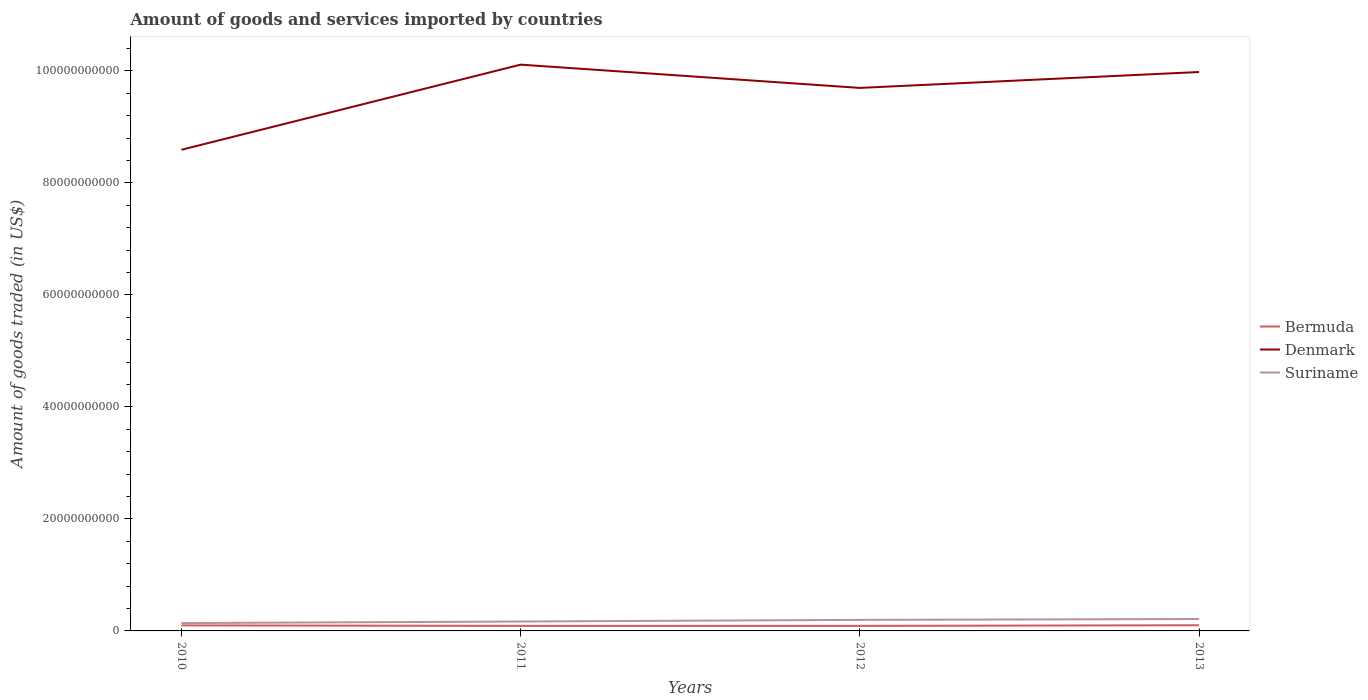How many different coloured lines are there?
Ensure brevity in your answer.  3. Across all years, what is the maximum total amount of goods and services imported in Denmark?
Offer a very short reply. 8.59e+1. What is the total total amount of goods and services imported in Suriname in the graph?
Give a very brief answer. -2.81e+08. What is the difference between the highest and the second highest total amount of goods and services imported in Denmark?
Your answer should be compact. 1.52e+1. What is the difference between the highest and the lowest total amount of goods and services imported in Bermuda?
Provide a short and direct response. 2. Is the total amount of goods and services imported in Denmark strictly greater than the total amount of goods and services imported in Suriname over the years?
Keep it short and to the point. No. What is the difference between two consecutive major ticks on the Y-axis?
Your response must be concise. 2.00e+1. Are the values on the major ticks of Y-axis written in scientific E-notation?
Your answer should be very brief. No. Does the graph contain any zero values?
Your answer should be compact. No. Does the graph contain grids?
Give a very brief answer. No. Where does the legend appear in the graph?
Provide a short and direct response. Center right. How many legend labels are there?
Your answer should be very brief. 3. How are the legend labels stacked?
Your answer should be very brief. Vertical. What is the title of the graph?
Offer a terse response. Amount of goods and services imported by countries. Does "Gambia, The" appear as one of the legend labels in the graph?
Your answer should be very brief. No. What is the label or title of the Y-axis?
Provide a succinct answer. Amount of goods traded (in US$). What is the Amount of goods traded (in US$) of Bermuda in 2010?
Provide a short and direct response. 9.88e+08. What is the Amount of goods traded (in US$) of Denmark in 2010?
Give a very brief answer. 8.59e+1. What is the Amount of goods traded (in US$) in Suriname in 2010?
Your answer should be very brief. 1.40e+09. What is the Amount of goods traded (in US$) in Bermuda in 2011?
Make the answer very short. 9.00e+08. What is the Amount of goods traded (in US$) of Denmark in 2011?
Offer a very short reply. 1.01e+11. What is the Amount of goods traded (in US$) in Suriname in 2011?
Offer a very short reply. 1.68e+09. What is the Amount of goods traded (in US$) of Bermuda in 2012?
Ensure brevity in your answer.  9.00e+08. What is the Amount of goods traded (in US$) in Denmark in 2012?
Offer a very short reply. 9.69e+1. What is the Amount of goods traded (in US$) of Suriname in 2012?
Keep it short and to the point. 1.97e+09. What is the Amount of goods traded (in US$) of Bermuda in 2013?
Make the answer very short. 1.01e+09. What is the Amount of goods traded (in US$) in Denmark in 2013?
Provide a succinct answer. 9.98e+1. What is the Amount of goods traded (in US$) in Suriname in 2013?
Keep it short and to the point. 2.13e+09. Across all years, what is the maximum Amount of goods traded (in US$) of Bermuda?
Make the answer very short. 1.01e+09. Across all years, what is the maximum Amount of goods traded (in US$) of Denmark?
Provide a succinct answer. 1.01e+11. Across all years, what is the maximum Amount of goods traded (in US$) of Suriname?
Offer a terse response. 2.13e+09. Across all years, what is the minimum Amount of goods traded (in US$) of Bermuda?
Your response must be concise. 9.00e+08. Across all years, what is the minimum Amount of goods traded (in US$) in Denmark?
Provide a succinct answer. 8.59e+1. Across all years, what is the minimum Amount of goods traded (in US$) in Suriname?
Provide a short and direct response. 1.40e+09. What is the total Amount of goods traded (in US$) of Bermuda in the graph?
Your response must be concise. 3.80e+09. What is the total Amount of goods traded (in US$) of Denmark in the graph?
Provide a succinct answer. 3.84e+11. What is the total Amount of goods traded (in US$) in Suriname in the graph?
Ensure brevity in your answer.  7.17e+09. What is the difference between the Amount of goods traded (in US$) in Bermuda in 2010 and that in 2011?
Your answer should be compact. 8.76e+07. What is the difference between the Amount of goods traded (in US$) in Denmark in 2010 and that in 2011?
Give a very brief answer. -1.52e+1. What is the difference between the Amount of goods traded (in US$) in Suriname in 2010 and that in 2011?
Provide a short and direct response. -2.81e+08. What is the difference between the Amount of goods traded (in US$) in Bermuda in 2010 and that in 2012?
Provide a short and direct response. 8.77e+07. What is the difference between the Amount of goods traded (in US$) of Denmark in 2010 and that in 2012?
Offer a terse response. -1.10e+1. What is the difference between the Amount of goods traded (in US$) in Suriname in 2010 and that in 2012?
Provide a short and direct response. -5.74e+08. What is the difference between the Amount of goods traded (in US$) in Bermuda in 2010 and that in 2013?
Make the answer very short. -2.35e+07. What is the difference between the Amount of goods traded (in US$) in Denmark in 2010 and that in 2013?
Keep it short and to the point. -1.39e+1. What is the difference between the Amount of goods traded (in US$) in Suriname in 2010 and that in 2013?
Keep it short and to the point. -7.28e+08. What is the difference between the Amount of goods traded (in US$) of Bermuda in 2011 and that in 2012?
Offer a terse response. 5.14e+04. What is the difference between the Amount of goods traded (in US$) in Denmark in 2011 and that in 2012?
Offer a very short reply. 4.15e+09. What is the difference between the Amount of goods traded (in US$) of Suriname in 2011 and that in 2012?
Provide a short and direct response. -2.92e+08. What is the difference between the Amount of goods traded (in US$) of Bermuda in 2011 and that in 2013?
Keep it short and to the point. -1.11e+08. What is the difference between the Amount of goods traded (in US$) of Denmark in 2011 and that in 2013?
Provide a succinct answer. 1.32e+09. What is the difference between the Amount of goods traded (in US$) in Suriname in 2011 and that in 2013?
Provide a short and direct response. -4.47e+08. What is the difference between the Amount of goods traded (in US$) of Bermuda in 2012 and that in 2013?
Your response must be concise. -1.11e+08. What is the difference between the Amount of goods traded (in US$) in Denmark in 2012 and that in 2013?
Give a very brief answer. -2.84e+09. What is the difference between the Amount of goods traded (in US$) of Suriname in 2012 and that in 2013?
Ensure brevity in your answer.  -1.54e+08. What is the difference between the Amount of goods traded (in US$) of Bermuda in 2010 and the Amount of goods traded (in US$) of Denmark in 2011?
Your answer should be very brief. -1.00e+11. What is the difference between the Amount of goods traded (in US$) of Bermuda in 2010 and the Amount of goods traded (in US$) of Suriname in 2011?
Your response must be concise. -6.91e+08. What is the difference between the Amount of goods traded (in US$) of Denmark in 2010 and the Amount of goods traded (in US$) of Suriname in 2011?
Your response must be concise. 8.42e+1. What is the difference between the Amount of goods traded (in US$) of Bermuda in 2010 and the Amount of goods traded (in US$) of Denmark in 2012?
Offer a very short reply. -9.60e+1. What is the difference between the Amount of goods traded (in US$) of Bermuda in 2010 and the Amount of goods traded (in US$) of Suriname in 2012?
Your response must be concise. -9.84e+08. What is the difference between the Amount of goods traded (in US$) of Denmark in 2010 and the Amount of goods traded (in US$) of Suriname in 2012?
Your response must be concise. 8.39e+1. What is the difference between the Amount of goods traded (in US$) in Bermuda in 2010 and the Amount of goods traded (in US$) in Denmark in 2013?
Your response must be concise. -9.88e+1. What is the difference between the Amount of goods traded (in US$) in Bermuda in 2010 and the Amount of goods traded (in US$) in Suriname in 2013?
Provide a succinct answer. -1.14e+09. What is the difference between the Amount of goods traded (in US$) of Denmark in 2010 and the Amount of goods traded (in US$) of Suriname in 2013?
Keep it short and to the point. 8.38e+1. What is the difference between the Amount of goods traded (in US$) of Bermuda in 2011 and the Amount of goods traded (in US$) of Denmark in 2012?
Your answer should be compact. -9.60e+1. What is the difference between the Amount of goods traded (in US$) of Bermuda in 2011 and the Amount of goods traded (in US$) of Suriname in 2012?
Offer a terse response. -1.07e+09. What is the difference between the Amount of goods traded (in US$) in Denmark in 2011 and the Amount of goods traded (in US$) in Suriname in 2012?
Offer a terse response. 9.91e+1. What is the difference between the Amount of goods traded (in US$) in Bermuda in 2011 and the Amount of goods traded (in US$) in Denmark in 2013?
Offer a terse response. -9.89e+1. What is the difference between the Amount of goods traded (in US$) in Bermuda in 2011 and the Amount of goods traded (in US$) in Suriname in 2013?
Ensure brevity in your answer.  -1.23e+09. What is the difference between the Amount of goods traded (in US$) in Denmark in 2011 and the Amount of goods traded (in US$) in Suriname in 2013?
Make the answer very short. 9.90e+1. What is the difference between the Amount of goods traded (in US$) in Bermuda in 2012 and the Amount of goods traded (in US$) in Denmark in 2013?
Your answer should be very brief. -9.89e+1. What is the difference between the Amount of goods traded (in US$) in Bermuda in 2012 and the Amount of goods traded (in US$) in Suriname in 2013?
Offer a very short reply. -1.23e+09. What is the difference between the Amount of goods traded (in US$) in Denmark in 2012 and the Amount of goods traded (in US$) in Suriname in 2013?
Provide a succinct answer. 9.48e+1. What is the average Amount of goods traded (in US$) in Bermuda per year?
Offer a terse response. 9.50e+08. What is the average Amount of goods traded (in US$) of Denmark per year?
Provide a succinct answer. 9.59e+1. What is the average Amount of goods traded (in US$) in Suriname per year?
Provide a succinct answer. 1.79e+09. In the year 2010, what is the difference between the Amount of goods traded (in US$) in Bermuda and Amount of goods traded (in US$) in Denmark?
Offer a very short reply. -8.49e+1. In the year 2010, what is the difference between the Amount of goods traded (in US$) of Bermuda and Amount of goods traded (in US$) of Suriname?
Make the answer very short. -4.10e+08. In the year 2010, what is the difference between the Amount of goods traded (in US$) of Denmark and Amount of goods traded (in US$) of Suriname?
Your answer should be compact. 8.45e+1. In the year 2011, what is the difference between the Amount of goods traded (in US$) of Bermuda and Amount of goods traded (in US$) of Denmark?
Provide a short and direct response. -1.00e+11. In the year 2011, what is the difference between the Amount of goods traded (in US$) in Bermuda and Amount of goods traded (in US$) in Suriname?
Keep it short and to the point. -7.79e+08. In the year 2011, what is the difference between the Amount of goods traded (in US$) in Denmark and Amount of goods traded (in US$) in Suriname?
Your answer should be compact. 9.94e+1. In the year 2012, what is the difference between the Amount of goods traded (in US$) in Bermuda and Amount of goods traded (in US$) in Denmark?
Provide a succinct answer. -9.60e+1. In the year 2012, what is the difference between the Amount of goods traded (in US$) in Bermuda and Amount of goods traded (in US$) in Suriname?
Give a very brief answer. -1.07e+09. In the year 2012, what is the difference between the Amount of goods traded (in US$) of Denmark and Amount of goods traded (in US$) of Suriname?
Give a very brief answer. 9.50e+1. In the year 2013, what is the difference between the Amount of goods traded (in US$) of Bermuda and Amount of goods traded (in US$) of Denmark?
Keep it short and to the point. -9.88e+1. In the year 2013, what is the difference between the Amount of goods traded (in US$) of Bermuda and Amount of goods traded (in US$) of Suriname?
Make the answer very short. -1.11e+09. In the year 2013, what is the difference between the Amount of goods traded (in US$) of Denmark and Amount of goods traded (in US$) of Suriname?
Provide a succinct answer. 9.77e+1. What is the ratio of the Amount of goods traded (in US$) in Bermuda in 2010 to that in 2011?
Provide a short and direct response. 1.1. What is the ratio of the Amount of goods traded (in US$) in Denmark in 2010 to that in 2011?
Offer a terse response. 0.85. What is the ratio of the Amount of goods traded (in US$) of Suriname in 2010 to that in 2011?
Make the answer very short. 0.83. What is the ratio of the Amount of goods traded (in US$) of Bermuda in 2010 to that in 2012?
Ensure brevity in your answer.  1.1. What is the ratio of the Amount of goods traded (in US$) of Denmark in 2010 to that in 2012?
Your response must be concise. 0.89. What is the ratio of the Amount of goods traded (in US$) of Suriname in 2010 to that in 2012?
Ensure brevity in your answer.  0.71. What is the ratio of the Amount of goods traded (in US$) in Bermuda in 2010 to that in 2013?
Give a very brief answer. 0.98. What is the ratio of the Amount of goods traded (in US$) of Denmark in 2010 to that in 2013?
Make the answer very short. 0.86. What is the ratio of the Amount of goods traded (in US$) in Suriname in 2010 to that in 2013?
Offer a terse response. 0.66. What is the ratio of the Amount of goods traded (in US$) in Bermuda in 2011 to that in 2012?
Give a very brief answer. 1. What is the ratio of the Amount of goods traded (in US$) of Denmark in 2011 to that in 2012?
Offer a terse response. 1.04. What is the ratio of the Amount of goods traded (in US$) of Suriname in 2011 to that in 2012?
Keep it short and to the point. 0.85. What is the ratio of the Amount of goods traded (in US$) in Bermuda in 2011 to that in 2013?
Keep it short and to the point. 0.89. What is the ratio of the Amount of goods traded (in US$) in Denmark in 2011 to that in 2013?
Provide a succinct answer. 1.01. What is the ratio of the Amount of goods traded (in US$) in Suriname in 2011 to that in 2013?
Ensure brevity in your answer.  0.79. What is the ratio of the Amount of goods traded (in US$) of Bermuda in 2012 to that in 2013?
Make the answer very short. 0.89. What is the ratio of the Amount of goods traded (in US$) in Denmark in 2012 to that in 2013?
Your response must be concise. 0.97. What is the ratio of the Amount of goods traded (in US$) of Suriname in 2012 to that in 2013?
Your answer should be compact. 0.93. What is the difference between the highest and the second highest Amount of goods traded (in US$) in Bermuda?
Provide a succinct answer. 2.35e+07. What is the difference between the highest and the second highest Amount of goods traded (in US$) in Denmark?
Provide a succinct answer. 1.32e+09. What is the difference between the highest and the second highest Amount of goods traded (in US$) of Suriname?
Provide a short and direct response. 1.54e+08. What is the difference between the highest and the lowest Amount of goods traded (in US$) of Bermuda?
Offer a very short reply. 1.11e+08. What is the difference between the highest and the lowest Amount of goods traded (in US$) in Denmark?
Your answer should be compact. 1.52e+1. What is the difference between the highest and the lowest Amount of goods traded (in US$) of Suriname?
Offer a very short reply. 7.28e+08. 